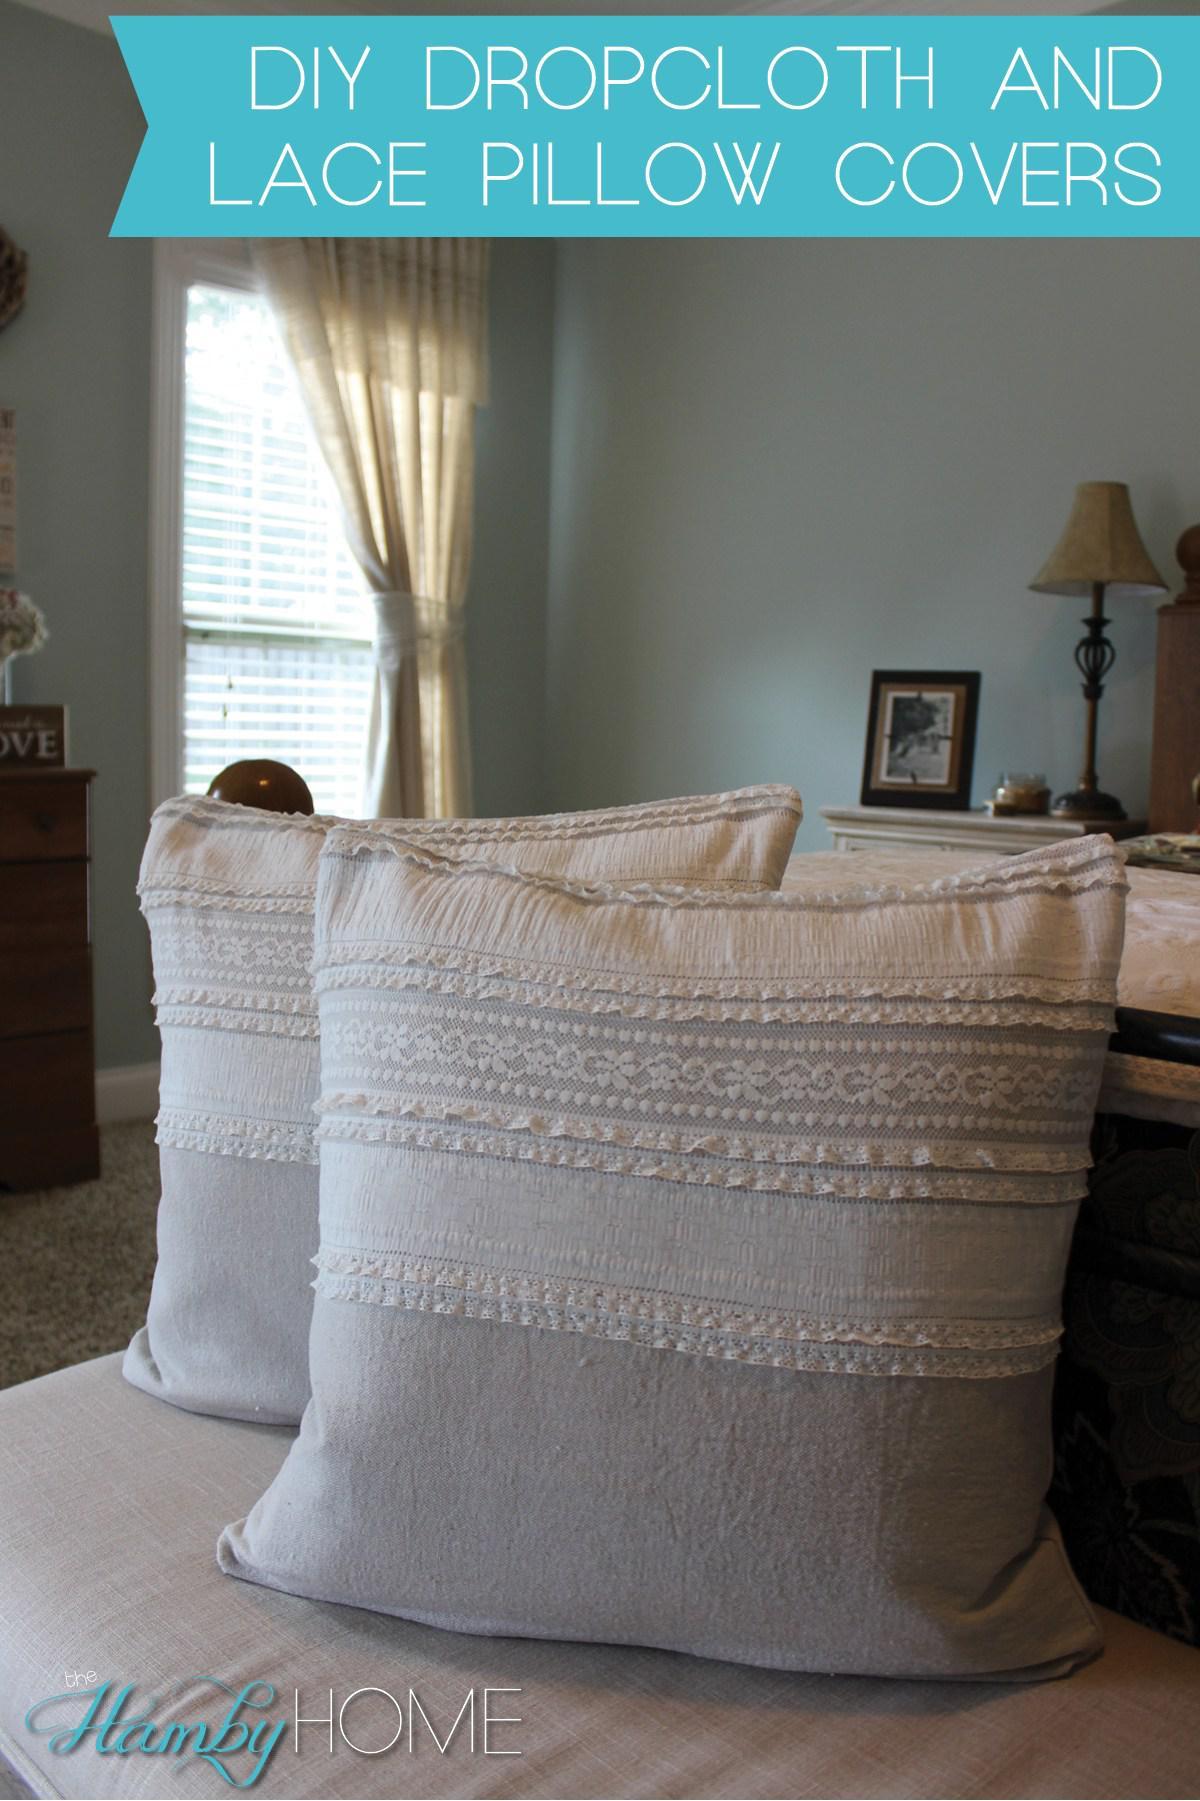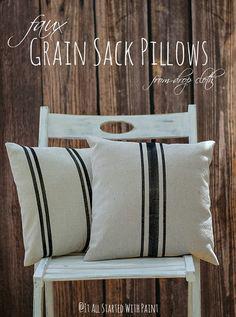The first image is the image on the left, the second image is the image on the right. Analyze the images presented: Is the assertion "There are two white pillows one in the back with two small strips pattern that repeat itself and a top pillow with 3 strips with the middle being the biggest." valid? Answer yes or no. Yes. The first image is the image on the left, the second image is the image on the right. Evaluate the accuracy of this statement regarding the images: "A square pillow with dark stripes down the middle is overlapping another pillow with stripes and displayed on a woodgrain surface, in the right image.". Is it true? Answer yes or no. Yes. 